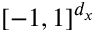Convert formula to latex. <formula><loc_0><loc_0><loc_500><loc_500>[ - 1 , 1 ] ^ { d _ { x } }</formula> 